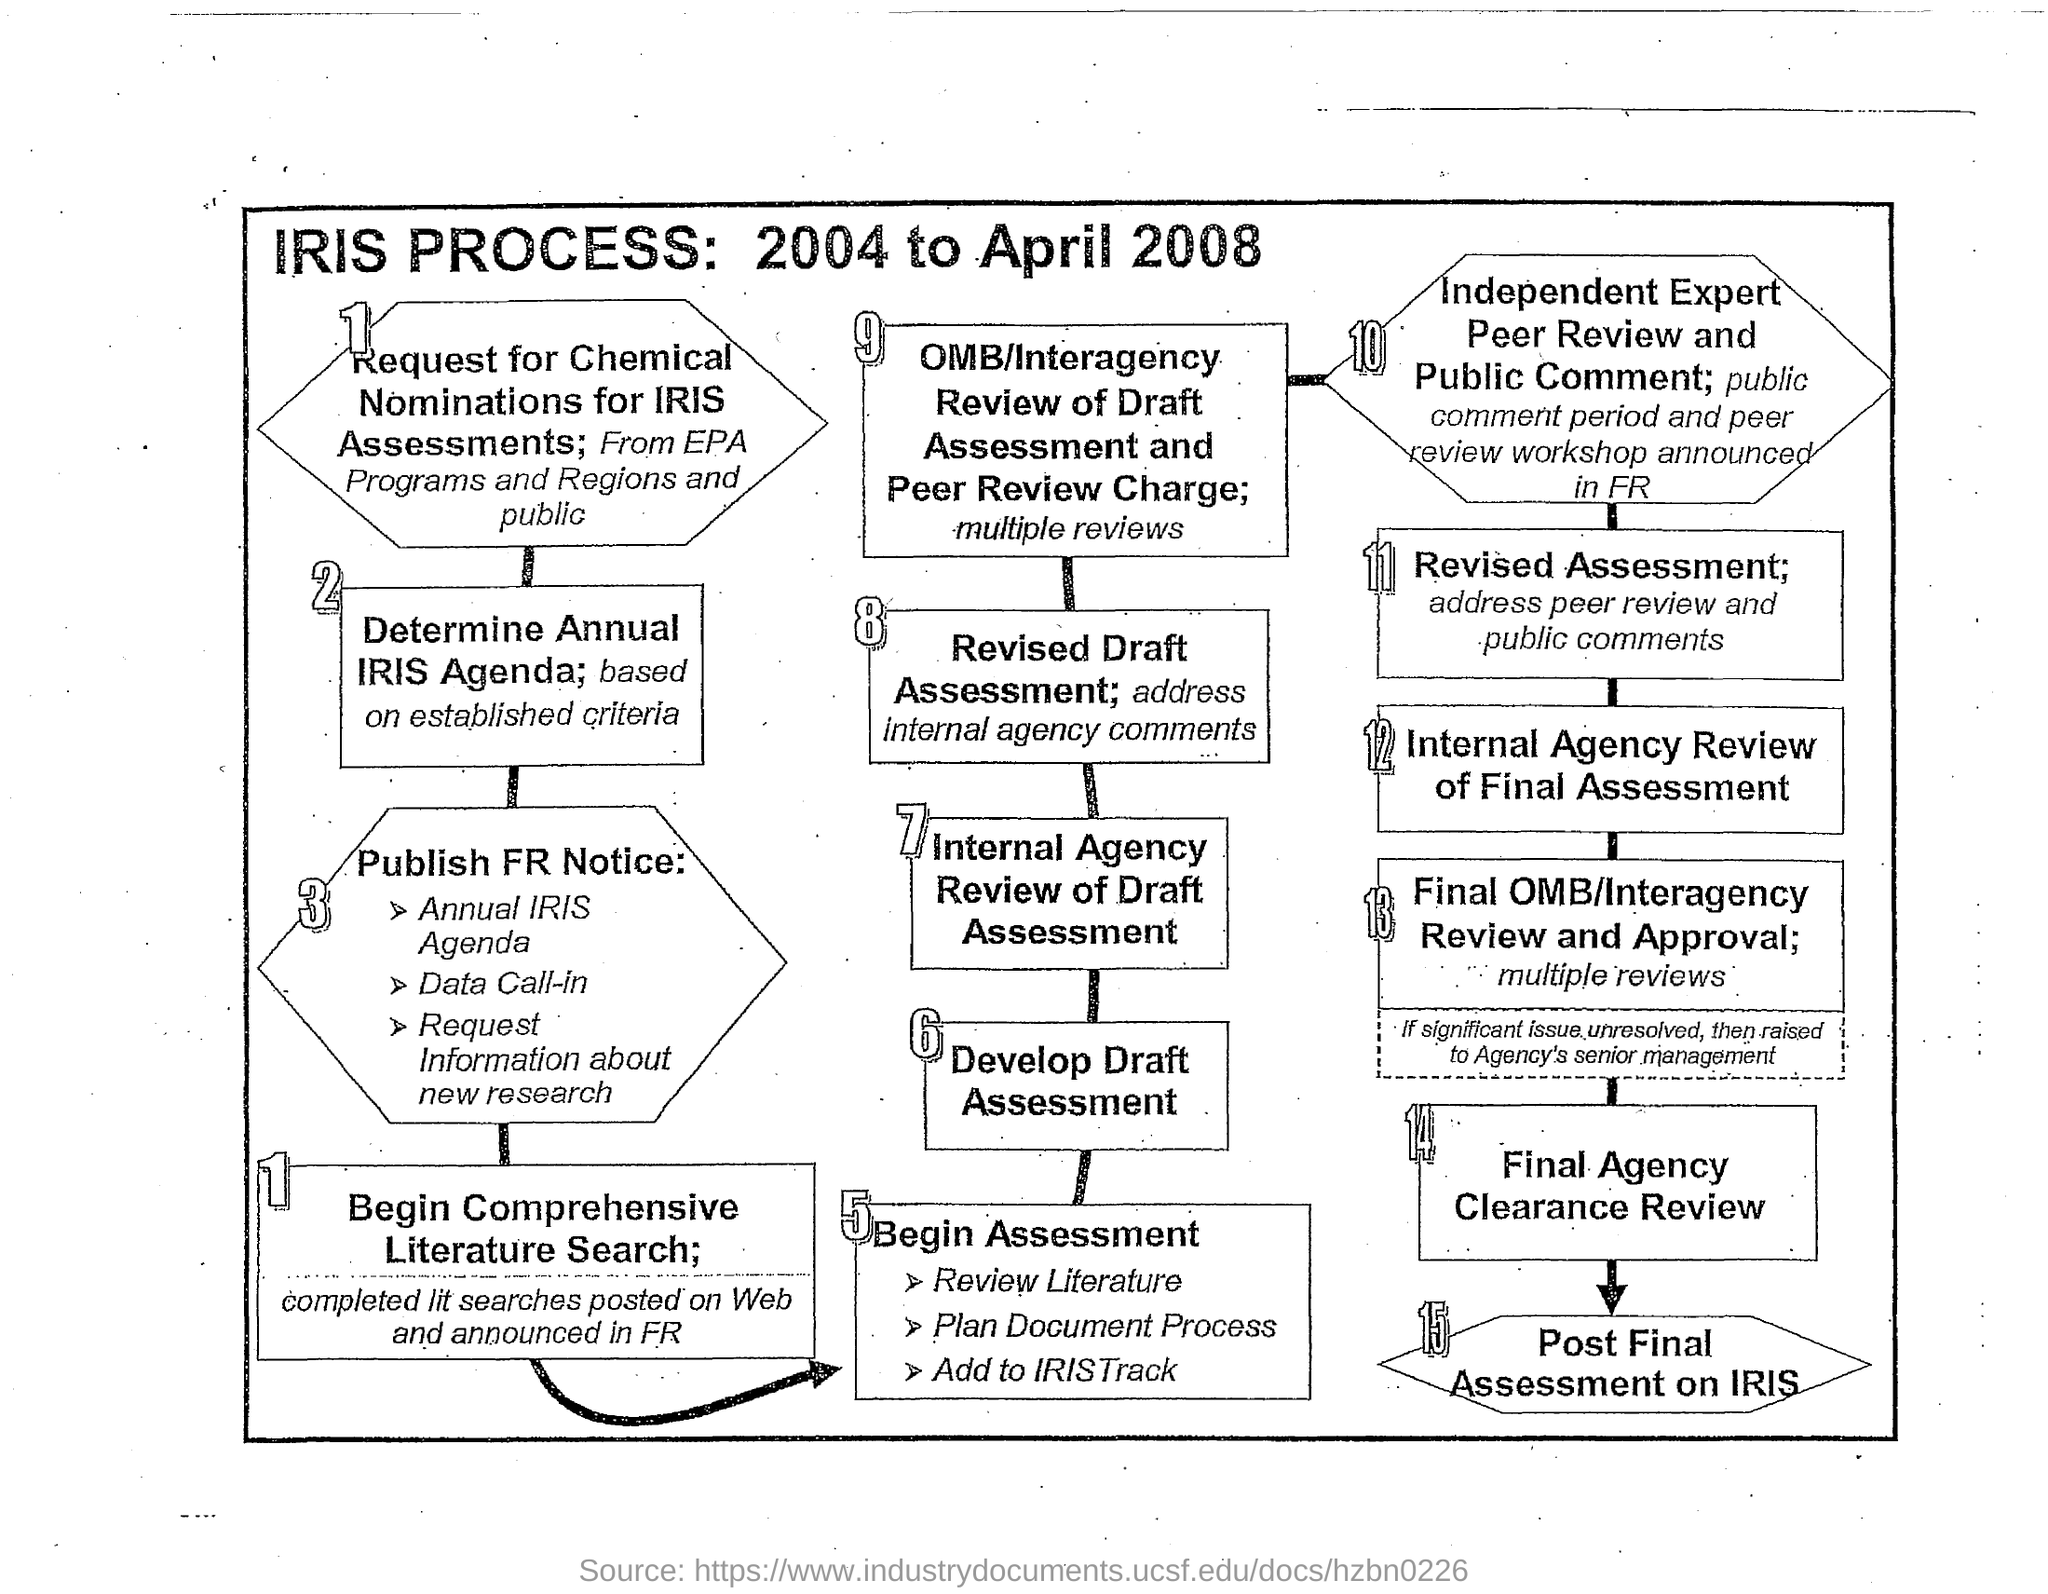Specify some key components in this picture. The IRIS process is the process given in the flowchart. 